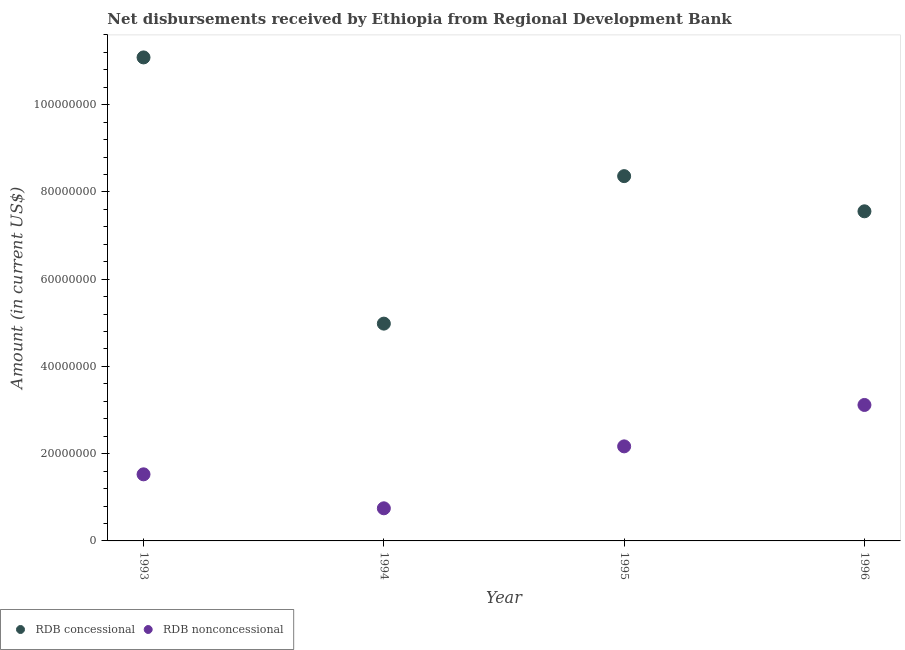What is the net concessional disbursements from rdb in 1994?
Your answer should be compact. 4.98e+07. Across all years, what is the maximum net non concessional disbursements from rdb?
Make the answer very short. 3.12e+07. Across all years, what is the minimum net non concessional disbursements from rdb?
Your response must be concise. 7.48e+06. In which year was the net non concessional disbursements from rdb minimum?
Ensure brevity in your answer.  1994. What is the total net concessional disbursements from rdb in the graph?
Keep it short and to the point. 3.20e+08. What is the difference between the net concessional disbursements from rdb in 1994 and that in 1996?
Give a very brief answer. -2.57e+07. What is the difference between the net non concessional disbursements from rdb in 1993 and the net concessional disbursements from rdb in 1995?
Ensure brevity in your answer.  -6.84e+07. What is the average net non concessional disbursements from rdb per year?
Your answer should be very brief. 1.89e+07. In the year 1994, what is the difference between the net non concessional disbursements from rdb and net concessional disbursements from rdb?
Your answer should be compact. -4.23e+07. What is the ratio of the net concessional disbursements from rdb in 1993 to that in 1994?
Provide a succinct answer. 2.23. Is the difference between the net non concessional disbursements from rdb in 1995 and 1996 greater than the difference between the net concessional disbursements from rdb in 1995 and 1996?
Your response must be concise. No. What is the difference between the highest and the second highest net non concessional disbursements from rdb?
Your answer should be very brief. 9.49e+06. What is the difference between the highest and the lowest net non concessional disbursements from rdb?
Keep it short and to the point. 2.37e+07. In how many years, is the net non concessional disbursements from rdb greater than the average net non concessional disbursements from rdb taken over all years?
Give a very brief answer. 2. Is the net non concessional disbursements from rdb strictly greater than the net concessional disbursements from rdb over the years?
Your answer should be compact. No. Is the net concessional disbursements from rdb strictly less than the net non concessional disbursements from rdb over the years?
Provide a short and direct response. No. What is the difference between two consecutive major ticks on the Y-axis?
Your response must be concise. 2.00e+07. Are the values on the major ticks of Y-axis written in scientific E-notation?
Offer a very short reply. No. How many legend labels are there?
Your response must be concise. 2. What is the title of the graph?
Ensure brevity in your answer.  Net disbursements received by Ethiopia from Regional Development Bank. Does "Current education expenditure" appear as one of the legend labels in the graph?
Your answer should be very brief. No. What is the label or title of the Y-axis?
Provide a succinct answer. Amount (in current US$). What is the Amount (in current US$) in RDB concessional in 1993?
Provide a succinct answer. 1.11e+08. What is the Amount (in current US$) in RDB nonconcessional in 1993?
Your answer should be compact. 1.53e+07. What is the Amount (in current US$) of RDB concessional in 1994?
Offer a very short reply. 4.98e+07. What is the Amount (in current US$) in RDB nonconcessional in 1994?
Your response must be concise. 7.48e+06. What is the Amount (in current US$) in RDB concessional in 1995?
Your answer should be compact. 8.36e+07. What is the Amount (in current US$) in RDB nonconcessional in 1995?
Provide a short and direct response. 2.17e+07. What is the Amount (in current US$) in RDB concessional in 1996?
Give a very brief answer. 7.56e+07. What is the Amount (in current US$) of RDB nonconcessional in 1996?
Your response must be concise. 3.12e+07. Across all years, what is the maximum Amount (in current US$) in RDB concessional?
Ensure brevity in your answer.  1.11e+08. Across all years, what is the maximum Amount (in current US$) in RDB nonconcessional?
Offer a terse response. 3.12e+07. Across all years, what is the minimum Amount (in current US$) in RDB concessional?
Provide a short and direct response. 4.98e+07. Across all years, what is the minimum Amount (in current US$) of RDB nonconcessional?
Provide a succinct answer. 7.48e+06. What is the total Amount (in current US$) of RDB concessional in the graph?
Your answer should be compact. 3.20e+08. What is the total Amount (in current US$) in RDB nonconcessional in the graph?
Make the answer very short. 7.56e+07. What is the difference between the Amount (in current US$) in RDB concessional in 1993 and that in 1994?
Your response must be concise. 6.10e+07. What is the difference between the Amount (in current US$) in RDB nonconcessional in 1993 and that in 1994?
Your answer should be compact. 7.79e+06. What is the difference between the Amount (in current US$) of RDB concessional in 1993 and that in 1995?
Give a very brief answer. 2.72e+07. What is the difference between the Amount (in current US$) in RDB nonconcessional in 1993 and that in 1995?
Your answer should be very brief. -6.41e+06. What is the difference between the Amount (in current US$) in RDB concessional in 1993 and that in 1996?
Your answer should be very brief. 3.53e+07. What is the difference between the Amount (in current US$) in RDB nonconcessional in 1993 and that in 1996?
Provide a succinct answer. -1.59e+07. What is the difference between the Amount (in current US$) in RDB concessional in 1994 and that in 1995?
Provide a succinct answer. -3.38e+07. What is the difference between the Amount (in current US$) in RDB nonconcessional in 1994 and that in 1995?
Your response must be concise. -1.42e+07. What is the difference between the Amount (in current US$) of RDB concessional in 1994 and that in 1996?
Provide a short and direct response. -2.57e+07. What is the difference between the Amount (in current US$) in RDB nonconcessional in 1994 and that in 1996?
Offer a terse response. -2.37e+07. What is the difference between the Amount (in current US$) of RDB concessional in 1995 and that in 1996?
Your answer should be very brief. 8.06e+06. What is the difference between the Amount (in current US$) in RDB nonconcessional in 1995 and that in 1996?
Your response must be concise. -9.49e+06. What is the difference between the Amount (in current US$) in RDB concessional in 1993 and the Amount (in current US$) in RDB nonconcessional in 1994?
Your response must be concise. 1.03e+08. What is the difference between the Amount (in current US$) of RDB concessional in 1993 and the Amount (in current US$) of RDB nonconcessional in 1995?
Provide a short and direct response. 8.92e+07. What is the difference between the Amount (in current US$) of RDB concessional in 1993 and the Amount (in current US$) of RDB nonconcessional in 1996?
Your answer should be very brief. 7.97e+07. What is the difference between the Amount (in current US$) of RDB concessional in 1994 and the Amount (in current US$) of RDB nonconcessional in 1995?
Your answer should be compact. 2.81e+07. What is the difference between the Amount (in current US$) in RDB concessional in 1994 and the Amount (in current US$) in RDB nonconcessional in 1996?
Provide a succinct answer. 1.86e+07. What is the difference between the Amount (in current US$) in RDB concessional in 1995 and the Amount (in current US$) in RDB nonconcessional in 1996?
Your answer should be compact. 5.25e+07. What is the average Amount (in current US$) of RDB concessional per year?
Provide a short and direct response. 8.00e+07. What is the average Amount (in current US$) in RDB nonconcessional per year?
Your answer should be very brief. 1.89e+07. In the year 1993, what is the difference between the Amount (in current US$) of RDB concessional and Amount (in current US$) of RDB nonconcessional?
Offer a very short reply. 9.56e+07. In the year 1994, what is the difference between the Amount (in current US$) in RDB concessional and Amount (in current US$) in RDB nonconcessional?
Offer a terse response. 4.23e+07. In the year 1995, what is the difference between the Amount (in current US$) in RDB concessional and Amount (in current US$) in RDB nonconcessional?
Offer a terse response. 6.20e+07. In the year 1996, what is the difference between the Amount (in current US$) of RDB concessional and Amount (in current US$) of RDB nonconcessional?
Your answer should be compact. 4.44e+07. What is the ratio of the Amount (in current US$) in RDB concessional in 1993 to that in 1994?
Provide a succinct answer. 2.23. What is the ratio of the Amount (in current US$) in RDB nonconcessional in 1993 to that in 1994?
Your answer should be compact. 2.04. What is the ratio of the Amount (in current US$) of RDB concessional in 1993 to that in 1995?
Make the answer very short. 1.33. What is the ratio of the Amount (in current US$) of RDB nonconcessional in 1993 to that in 1995?
Give a very brief answer. 0.7. What is the ratio of the Amount (in current US$) in RDB concessional in 1993 to that in 1996?
Provide a succinct answer. 1.47. What is the ratio of the Amount (in current US$) of RDB nonconcessional in 1993 to that in 1996?
Offer a very short reply. 0.49. What is the ratio of the Amount (in current US$) of RDB concessional in 1994 to that in 1995?
Offer a very short reply. 0.6. What is the ratio of the Amount (in current US$) of RDB nonconcessional in 1994 to that in 1995?
Offer a terse response. 0.34. What is the ratio of the Amount (in current US$) in RDB concessional in 1994 to that in 1996?
Provide a short and direct response. 0.66. What is the ratio of the Amount (in current US$) in RDB nonconcessional in 1994 to that in 1996?
Ensure brevity in your answer.  0.24. What is the ratio of the Amount (in current US$) of RDB concessional in 1995 to that in 1996?
Make the answer very short. 1.11. What is the ratio of the Amount (in current US$) of RDB nonconcessional in 1995 to that in 1996?
Provide a succinct answer. 0.7. What is the difference between the highest and the second highest Amount (in current US$) in RDB concessional?
Your response must be concise. 2.72e+07. What is the difference between the highest and the second highest Amount (in current US$) in RDB nonconcessional?
Ensure brevity in your answer.  9.49e+06. What is the difference between the highest and the lowest Amount (in current US$) in RDB concessional?
Your response must be concise. 6.10e+07. What is the difference between the highest and the lowest Amount (in current US$) of RDB nonconcessional?
Your response must be concise. 2.37e+07. 